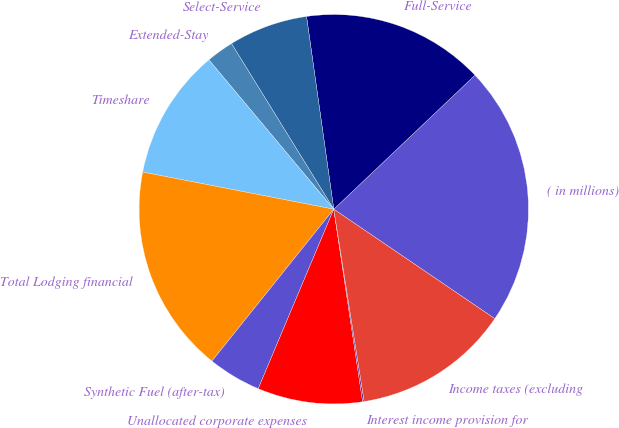Convert chart to OTSL. <chart><loc_0><loc_0><loc_500><loc_500><pie_chart><fcel>( in millions)<fcel>Full-Service<fcel>Select-Service<fcel>Extended-Stay<fcel>Timeshare<fcel>Total Lodging financial<fcel>Synthetic Fuel (after-tax)<fcel>Unallocated corporate expenses<fcel>Interest income provision for<fcel>Income taxes (excluding<nl><fcel>21.59%<fcel>15.15%<fcel>6.57%<fcel>2.28%<fcel>10.86%<fcel>17.3%<fcel>4.42%<fcel>8.71%<fcel>0.13%<fcel>13.0%<nl></chart> 